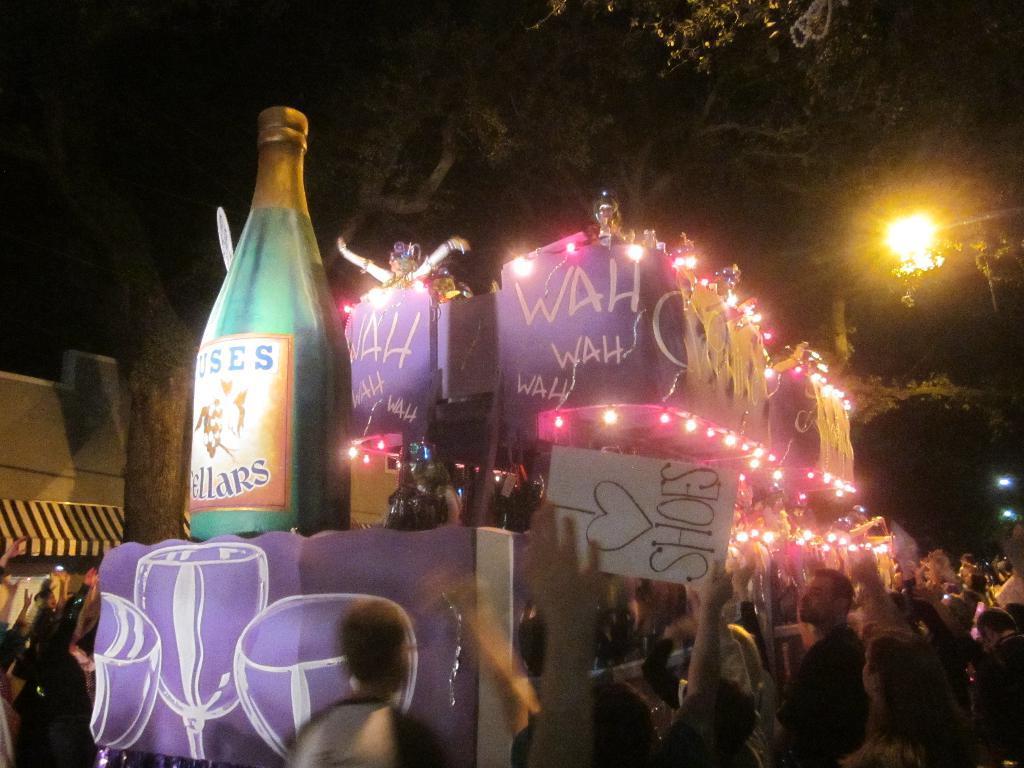Please provide a concise description of this image. In this image we can see some persons, name board, decorative items, trees, lights and other objects. At the top of the image there are trees, lights and other objects. 